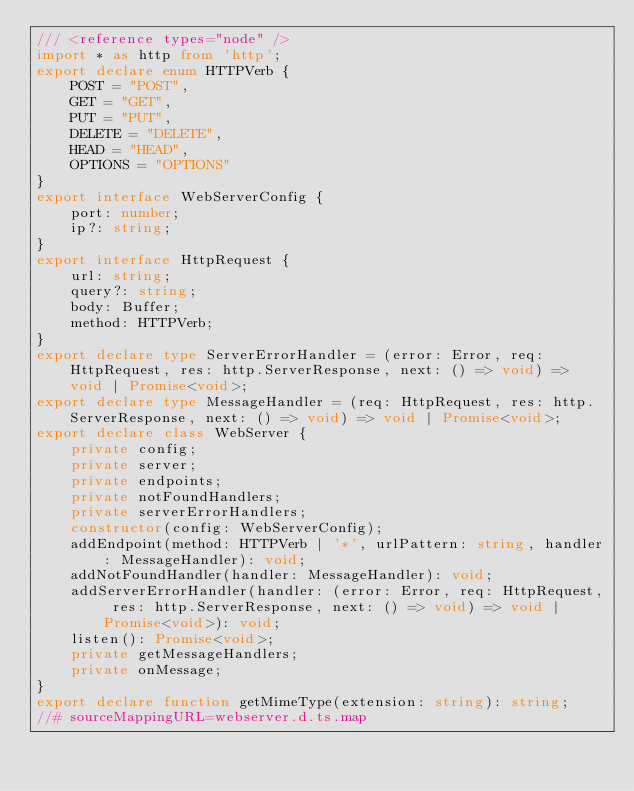Convert code to text. <code><loc_0><loc_0><loc_500><loc_500><_TypeScript_>/// <reference types="node" />
import * as http from 'http';
export declare enum HTTPVerb {
    POST = "POST",
    GET = "GET",
    PUT = "PUT",
    DELETE = "DELETE",
    HEAD = "HEAD",
    OPTIONS = "OPTIONS"
}
export interface WebServerConfig {
    port: number;
    ip?: string;
}
export interface HttpRequest {
    url: string;
    query?: string;
    body: Buffer;
    method: HTTPVerb;
}
export declare type ServerErrorHandler = (error: Error, req: HttpRequest, res: http.ServerResponse, next: () => void) => void | Promise<void>;
export declare type MessageHandler = (req: HttpRequest, res: http.ServerResponse, next: () => void) => void | Promise<void>;
export declare class WebServer {
    private config;
    private server;
    private endpoints;
    private notFoundHandlers;
    private serverErrorHandlers;
    constructor(config: WebServerConfig);
    addEndpoint(method: HTTPVerb | '*', urlPattern: string, handler: MessageHandler): void;
    addNotFoundHandler(handler: MessageHandler): void;
    addServerErrorHandler(handler: (error: Error, req: HttpRequest, res: http.ServerResponse, next: () => void) => void | Promise<void>): void;
    listen(): Promise<void>;
    private getMessageHandlers;
    private onMessage;
}
export declare function getMimeType(extension: string): string;
//# sourceMappingURL=webserver.d.ts.map</code> 